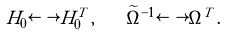<formula> <loc_0><loc_0><loc_500><loc_500>H _ { 0 } \longleftrightarrow H _ { 0 } ^ { T } \, , \quad \widetilde { \Omega } ^ { - 1 } \longleftrightarrow \Omega ^ { T } \, .</formula> 